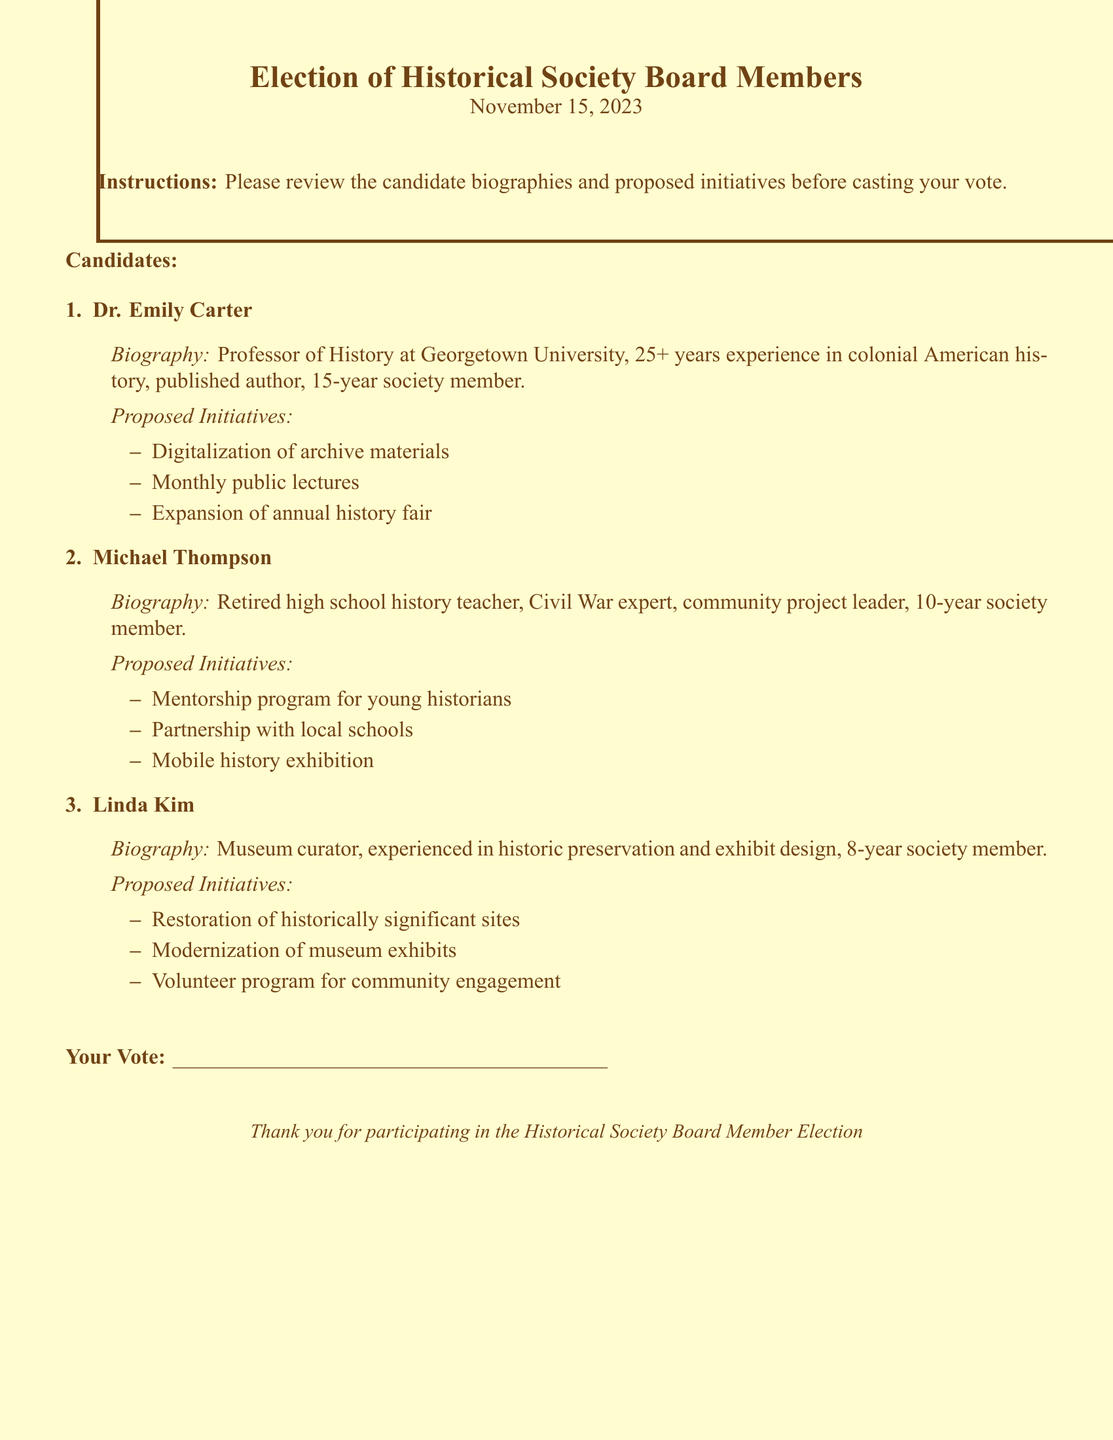What is the date of the election? The date of the election is mentioned at the beginning of the document, which is November 15, 2023.
Answer: November 15, 2023 Who is the candidate with experience in colonial American history? The candidate who is a Professor of History and has 25+ years experience in colonial American history is Dr. Emily Carter.
Answer: Dr. Emily Carter What is one initiative proposed by Michael Thompson? One of the proposed initiatives listed for Michael Thompson is a mentorship program for young historians.
Answer: Mentorship program for young historians How many years has Linda Kim been a society member? The document states that Linda Kim has been a society member for 8 years.
Answer: 8 years What role does Dr. Emily Carter currently hold? The document describes Dr. Emily Carter as a Professor of History at Georgetown University.
Answer: Professor of History Which candidate proposed a mobile history exhibition? The candidate who proposed a mobile history exhibition is Michael Thompson.
Answer: Michael Thompson What is the total number of candidates listed? The document lists three candidates for the board member election.
Answer: Three What is the primary focus of Linda Kim's proposed initiatives? The initiatives proposed by Linda Kim mainly focus on historic preservation and community engagement.
Answer: Historic preservation and community engagement What is the main instruction provided to voters? The document instructs voters to review candidate biographies and proposed initiatives before casting their vote.
Answer: Review candidate biographies and proposed initiatives 